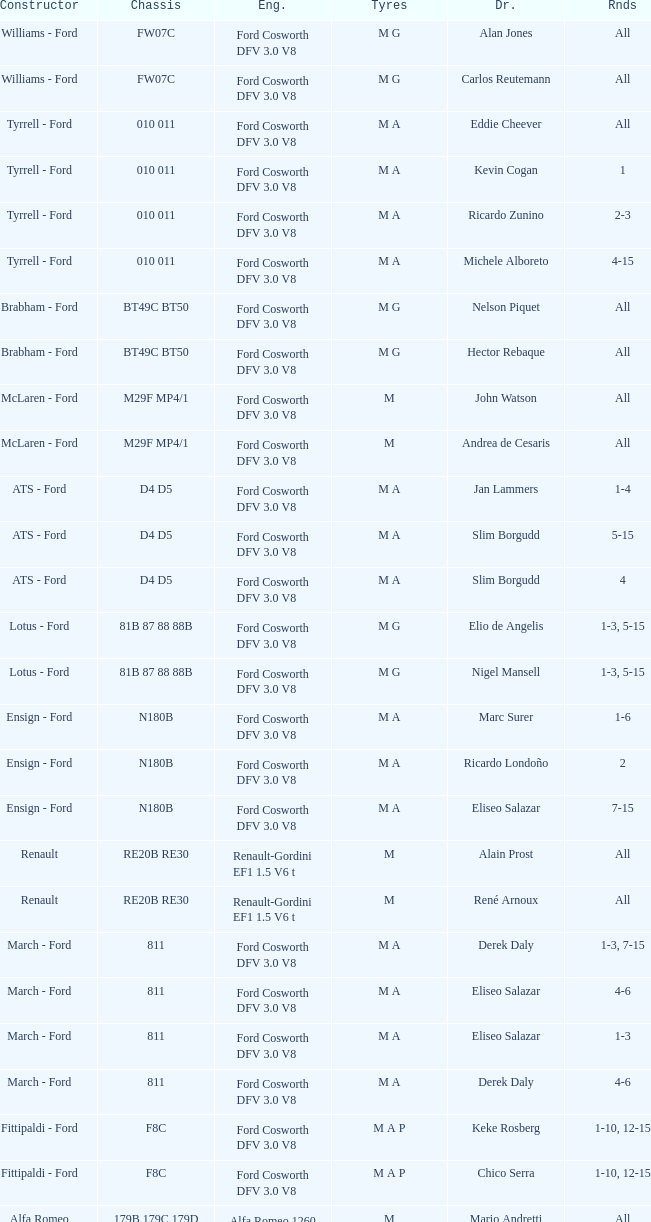Who constructed the car that Derek Warwick raced in with a TG181 chassis? Toleman - Hart. 